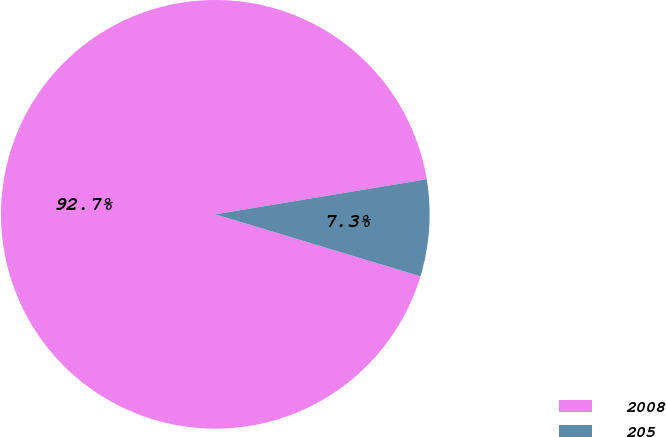Convert chart. <chart><loc_0><loc_0><loc_500><loc_500><pie_chart><fcel>2008<fcel>205<nl><fcel>92.71%<fcel>7.29%<nl></chart> 